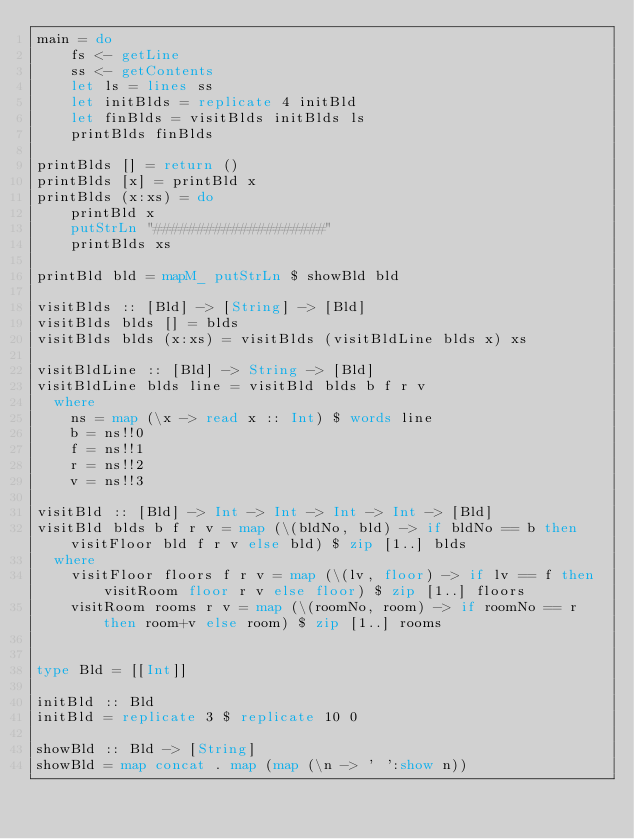<code> <loc_0><loc_0><loc_500><loc_500><_Haskell_>main = do
    fs <- getLine
    ss <- getContents
    let ls = lines ss
    let initBlds = replicate 4 initBld
    let finBlds = visitBlds initBlds ls
    printBlds finBlds

printBlds [] = return ()
printBlds [x] = printBld x
printBlds (x:xs) = do
    printBld x
    putStrLn "####################"
    printBlds xs

printBld bld = mapM_ putStrLn $ showBld bld

visitBlds :: [Bld] -> [String] -> [Bld]
visitBlds blds [] = blds
visitBlds blds (x:xs) = visitBlds (visitBldLine blds x) xs

visitBldLine :: [Bld] -> String -> [Bld]
visitBldLine blds line = visitBld blds b f r v
  where
    ns = map (\x -> read x :: Int) $ words line
    b = ns!!0
    f = ns!!1
    r = ns!!2
    v = ns!!3

visitBld :: [Bld] -> Int -> Int -> Int -> Int -> [Bld]
visitBld blds b f r v = map (\(bldNo, bld) -> if bldNo == b then visitFloor bld f r v else bld) $ zip [1..] blds
  where
    visitFloor floors f r v = map (\(lv, floor) -> if lv == f then visitRoom floor r v else floor) $ zip [1..] floors
    visitRoom rooms r v = map (\(roomNo, room) -> if roomNo == r then room+v else room) $ zip [1..] rooms


type Bld = [[Int]]

initBld :: Bld
initBld = replicate 3 $ replicate 10 0

showBld :: Bld -> [String]
showBld = map concat . map (map (\n -> ' ':show n))

</code> 